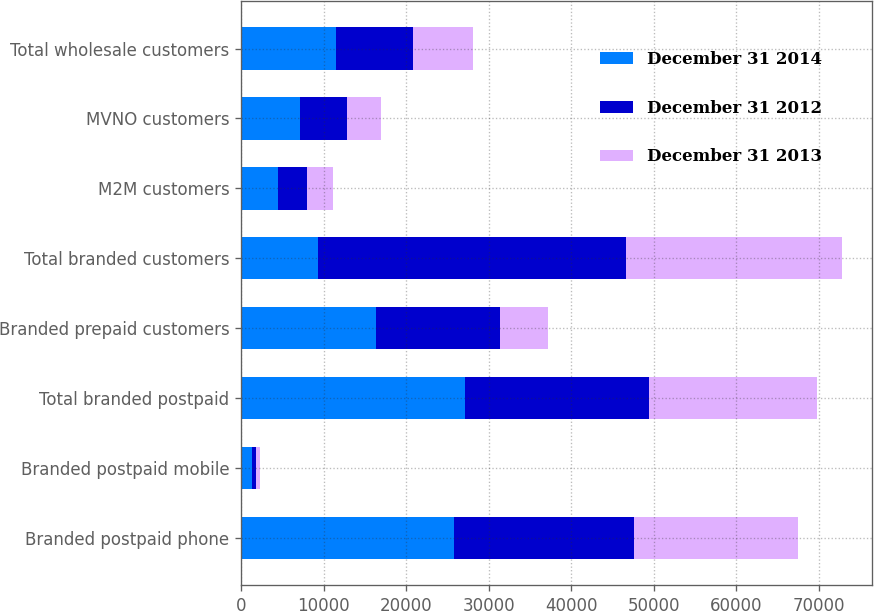<chart> <loc_0><loc_0><loc_500><loc_500><stacked_bar_chart><ecel><fcel>Branded postpaid phone<fcel>Branded postpaid mobile<fcel>Total branded postpaid<fcel>Branded prepaid customers<fcel>Total branded customers<fcel>M2M customers<fcel>MVNO customers<fcel>Total wholesale customers<nl><fcel>December 31 2014<fcel>25844<fcel>1341<fcel>27185<fcel>16316<fcel>9313<fcel>4421<fcel>7096<fcel>11517<nl><fcel>December 31 2012<fcel>21797<fcel>502<fcel>22299<fcel>15072<fcel>37371<fcel>3602<fcel>5711<fcel>9313<nl><fcel>December 31 2013<fcel>19858<fcel>435<fcel>20293<fcel>5826<fcel>26119<fcel>3090<fcel>4180<fcel>7270<nl></chart> 